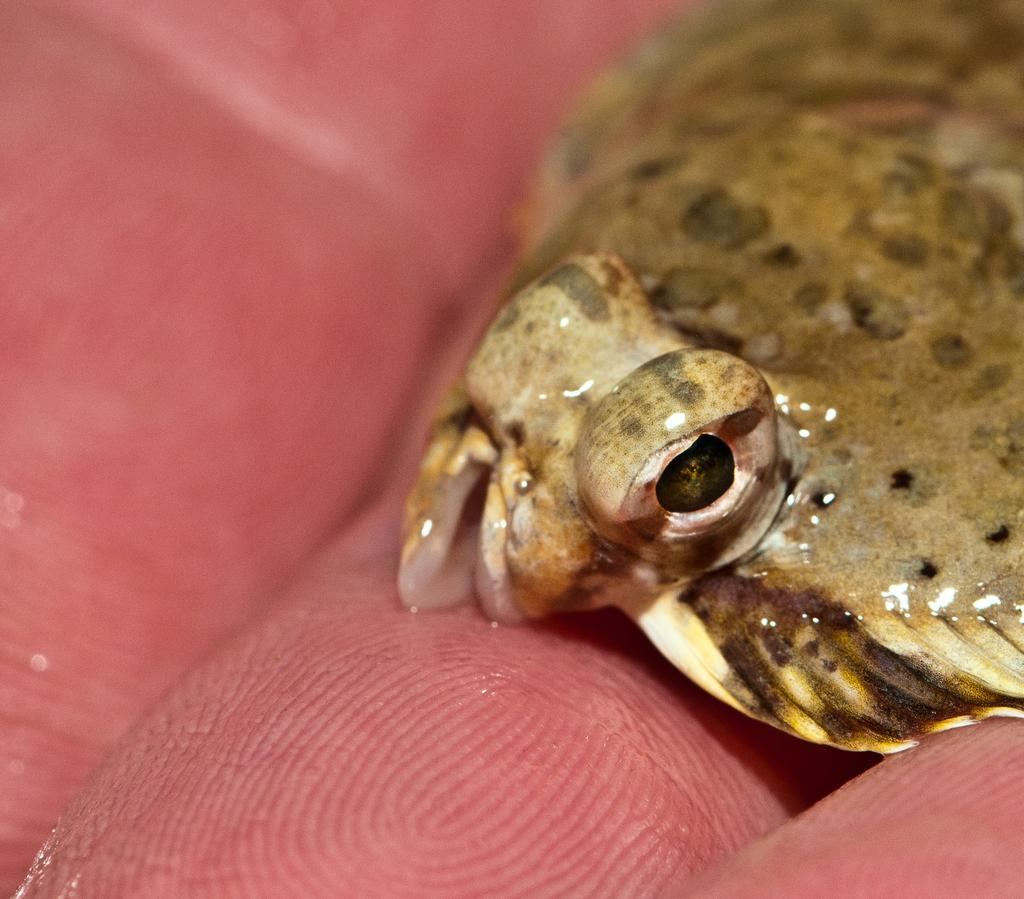What type of animal is in the image? There is an animal in the image, but the specific type cannot be determined from the provided facts. How is the animal positioned in the image? The animal is on the fingers of a person. What type of toad is sitting under the umbrella in the image? There is no toad or umbrella present in the image. 